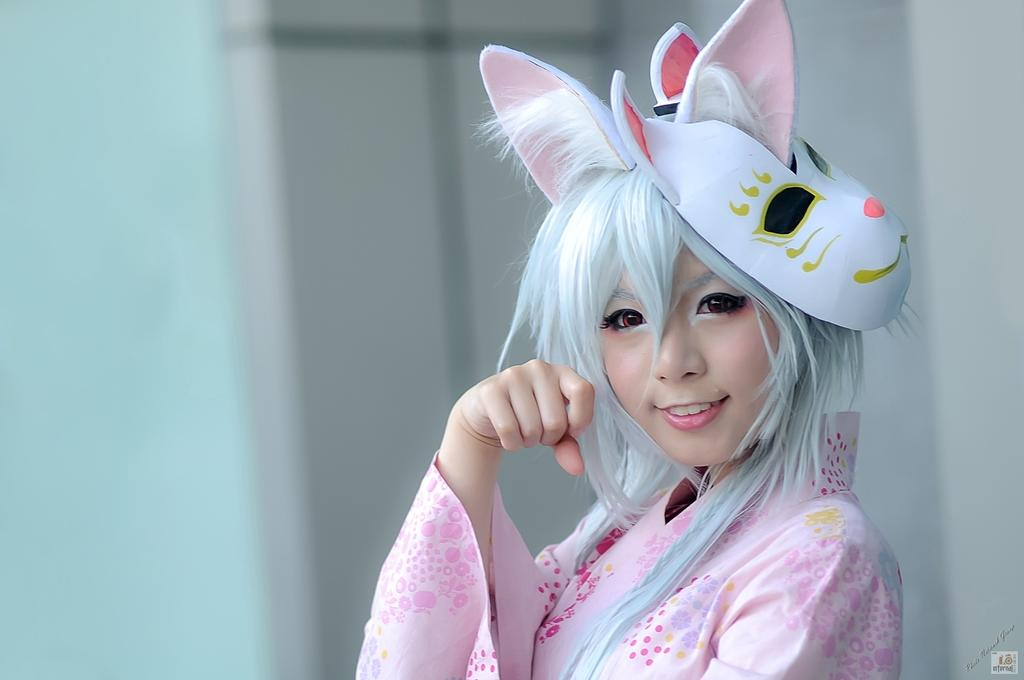What can be seen in the image? There is a person in the image. How is the person's expression? The person has a smile on their face. What is present at the bottom of the image? There is some text and a watermark at the bottom of the image. What type of brass stick is the person holding in the image? There is no brass stick present in the image. What kind of bag is the person carrying in the image? The image does not show the person carrying a bag. 